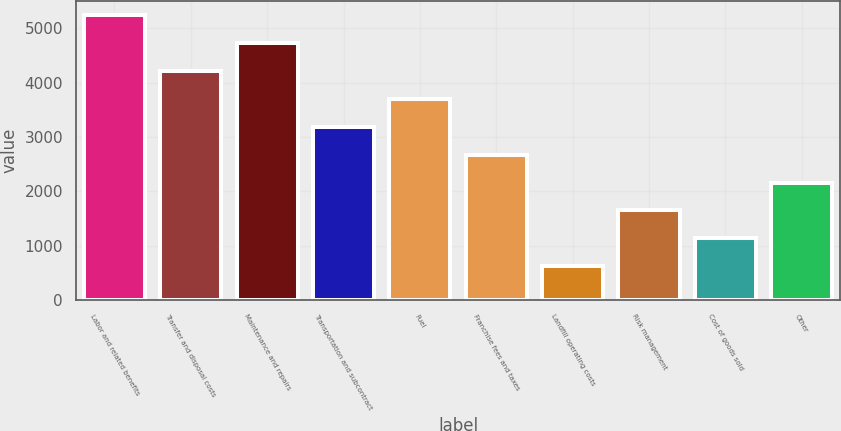Convert chart. <chart><loc_0><loc_0><loc_500><loc_500><bar_chart><fcel>Labor and related benefits<fcel>Transfer and disposal costs<fcel>Maintenance and repairs<fcel>Transportation and subcontract<fcel>Fuel<fcel>Franchise fees and taxes<fcel>Landfill operating costs<fcel>Risk management<fcel>Cost of goods sold<fcel>Other<nl><fcel>5234.7<fcel>4209.5<fcel>4722.1<fcel>3184.3<fcel>3696.9<fcel>2671.7<fcel>621.3<fcel>1646.5<fcel>1133.9<fcel>2159.1<nl></chart> 